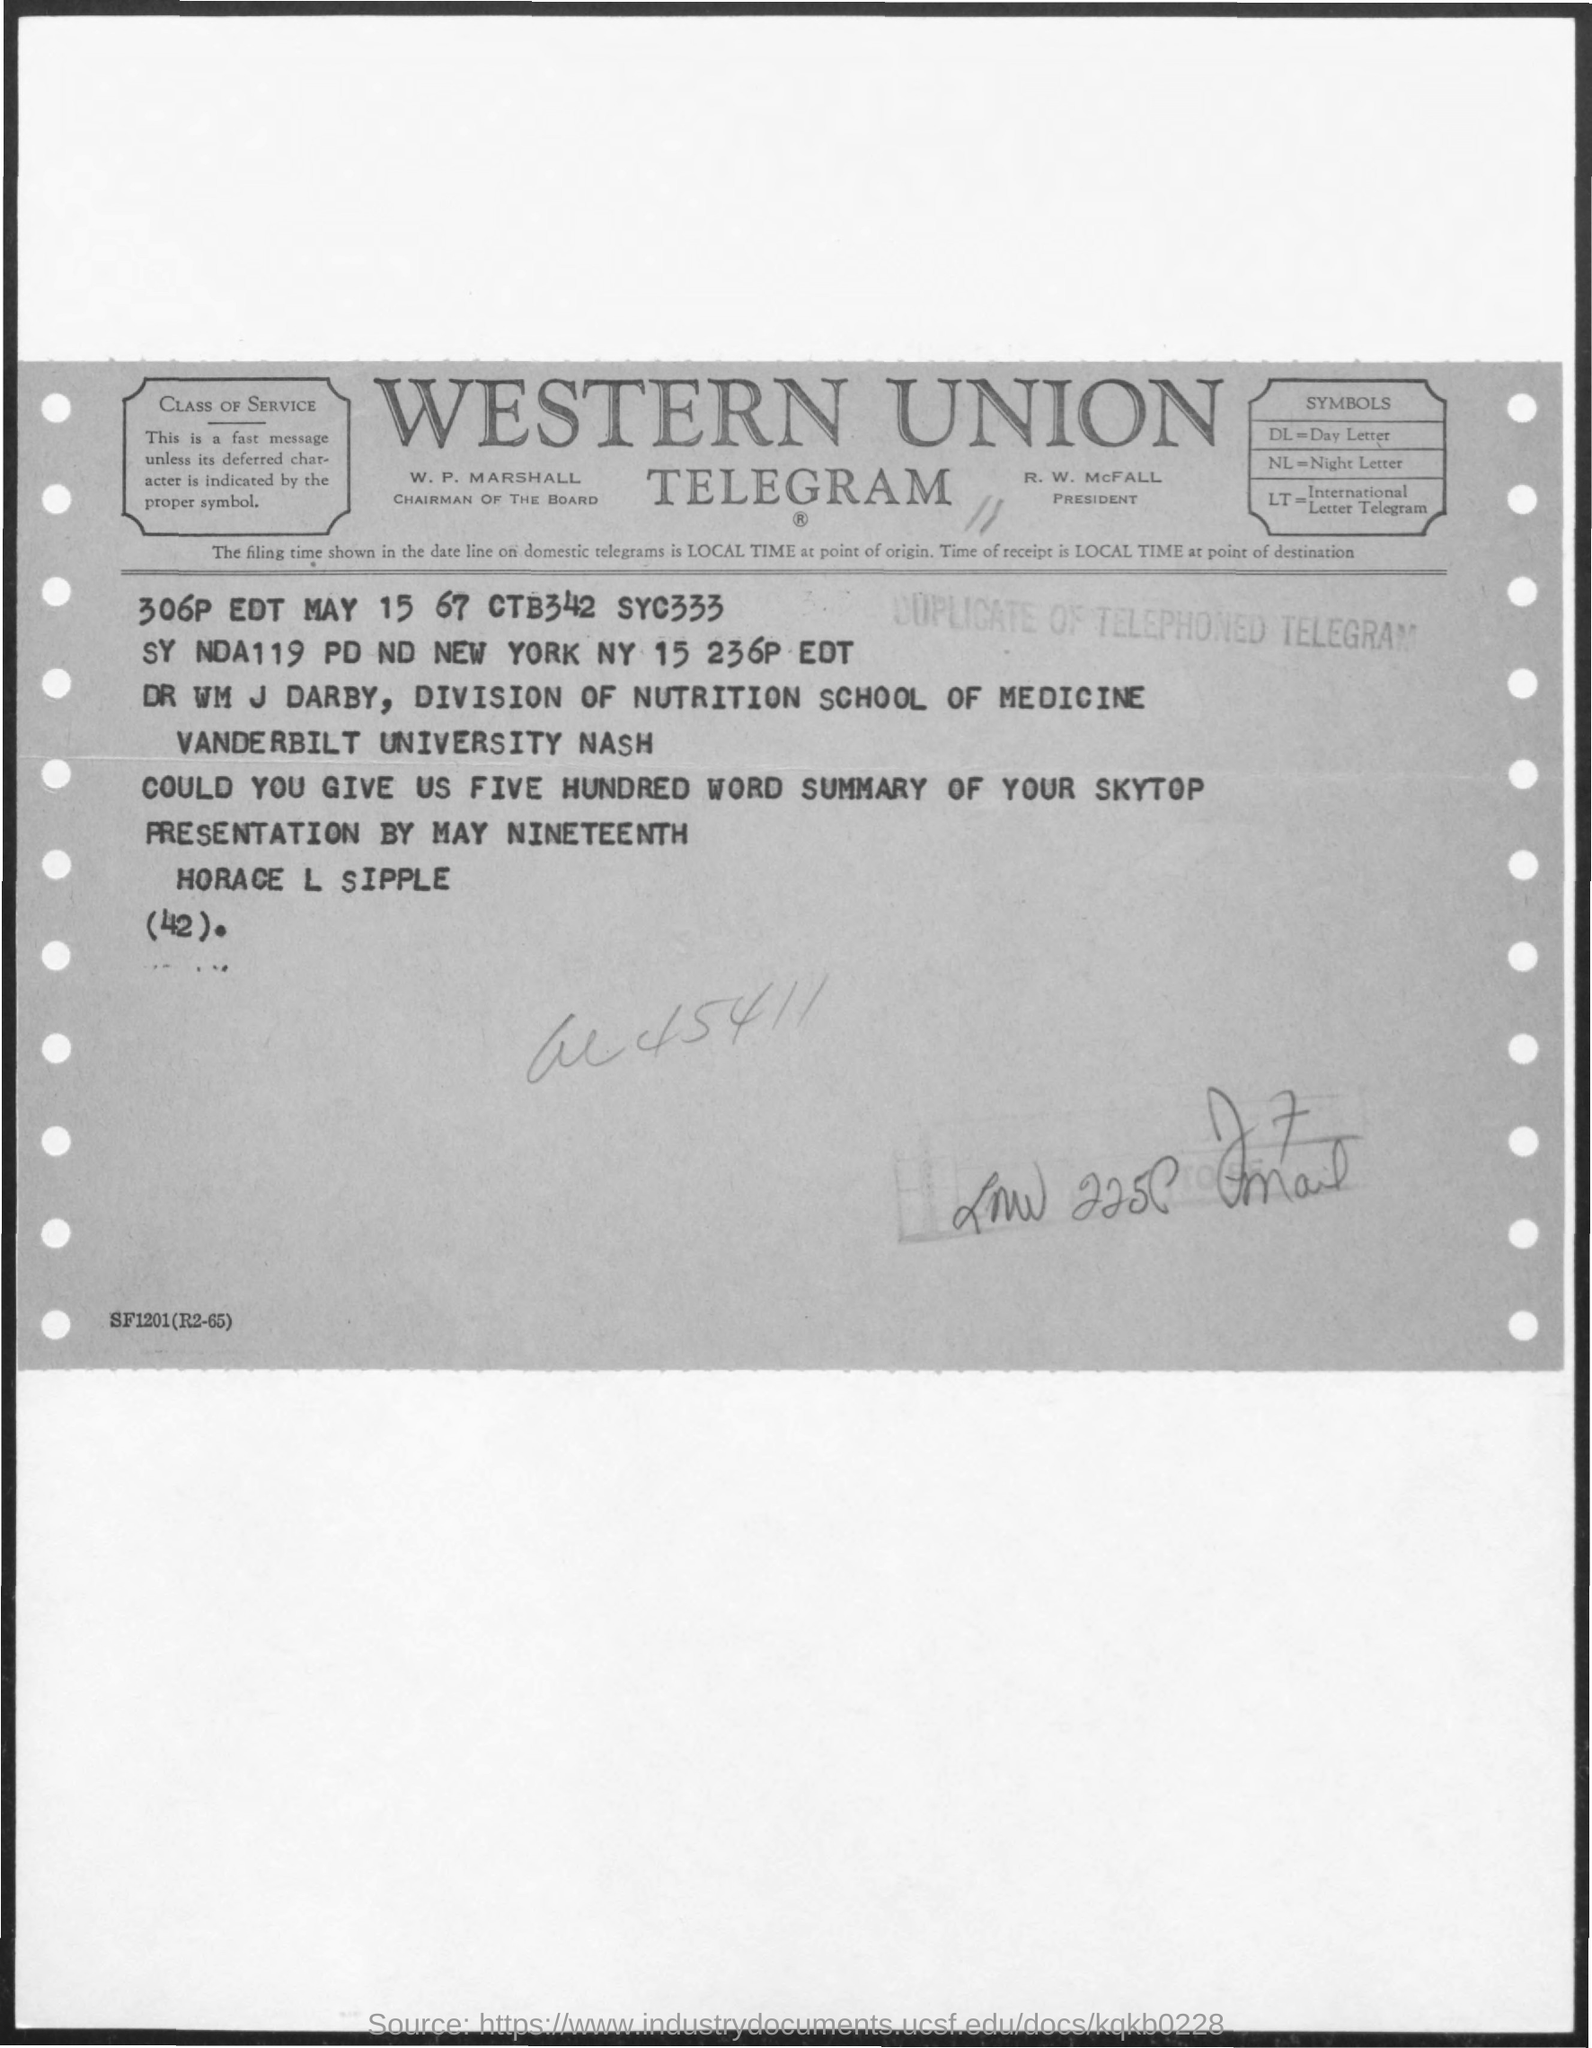Identify some key points in this picture. The acronym LT stands for International Letter Telegram. What does DL stand for? It stands for day letter. NL stands for "night letter," which refers to a type of handwritten letter that was commonly used during the night shift in factories. What is the name of the telegram? It is Western union. The president's name is R. W. McFall. 